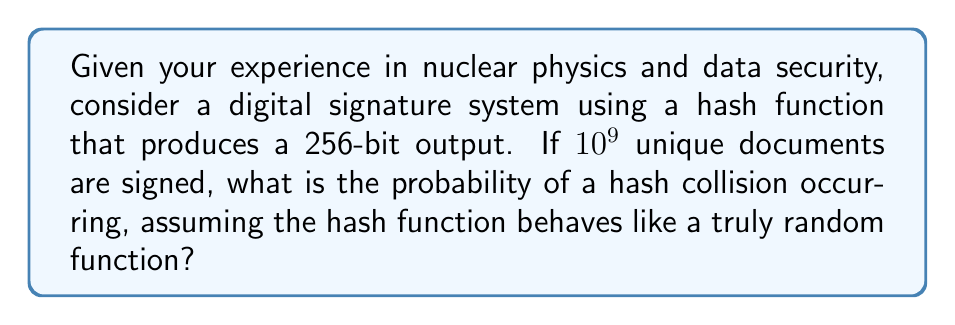Can you answer this question? Let's approach this step-by-step:

1) First, we need to understand the birthday problem, which is closely related to hash collisions. The birthday problem asks about the probability of a collision in a set of randomly chosen objects.

2) In this case, we have:
   - $n = 2^{256}$ possible hash values (size of the output space)
   - $k = 10^9$ documents (number of hash operations)

3) The probability of no collision is approximately:

   $$P(\text{no collision}) \approx e^{-k^2/(2n)}$$

4) Therefore, the probability of at least one collision is:

   $$P(\text{collision}) = 1 - P(\text{no collision}) \approx 1 - e^{-k^2/(2n)}$$

5) Let's substitute our values:

   $$P(\text{collision}) \approx 1 - e^{-(10^9)^2 / (2 \cdot 2^{256})}$$

6) Simplify:
   $$P(\text{collision}) \approx 1 - e^{-5 \cdot 10^{17} / 2^{257}}$$

7) Calculate:
   $$P(\text{collision}) \approx 1 - e^{-1.7 \cdot 10^{-60}}$$

8) Using the approximation $e^{-x} \approx 1 - x$ for small $x$:

   $$P(\text{collision}) \approx 1.7 \cdot 10^{-60}$$
Answer: $1.7 \cdot 10^{-60}$ 